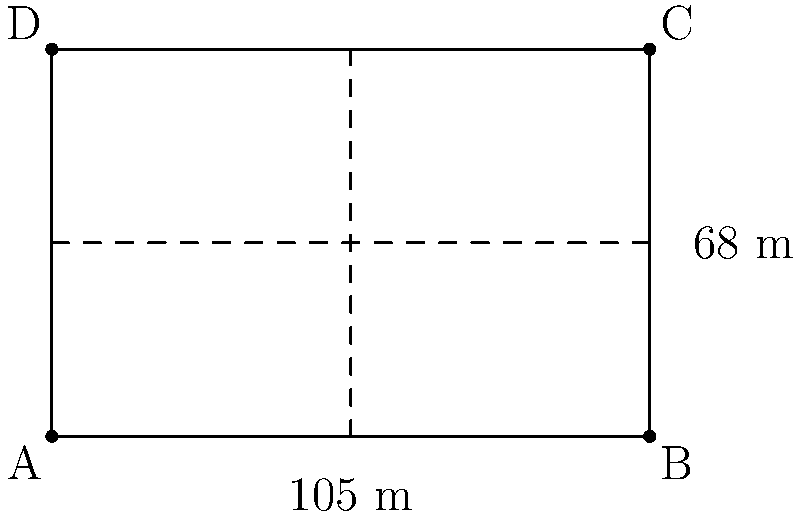As a devoted Hammarby Fotboll supporter, you're curious about the dimensions of your team's home ground, Tele2 Arena. The soccer field has a length of 105 meters and a width of 68 meters. What is the total area of the playing surface? To calculate the area of the soccer field, we need to follow these steps:

1. Identify the shape: The soccer field is a rectangle.

2. Recall the formula for the area of a rectangle:
   $$A = l \times w$$
   where $A$ is the area, $l$ is the length, and $w$ is the width.

3. Substitute the given dimensions:
   $l = 105$ meters
   $w = 68$ meters

4. Calculate the area:
   $$A = 105 \text{ m} \times 68 \text{ m} = 7,140 \text{ m}^2$$

Therefore, the total area of the Hammarby Fotboll playing surface at Tele2 Arena is 7,140 square meters.
Answer: 7,140 m² 